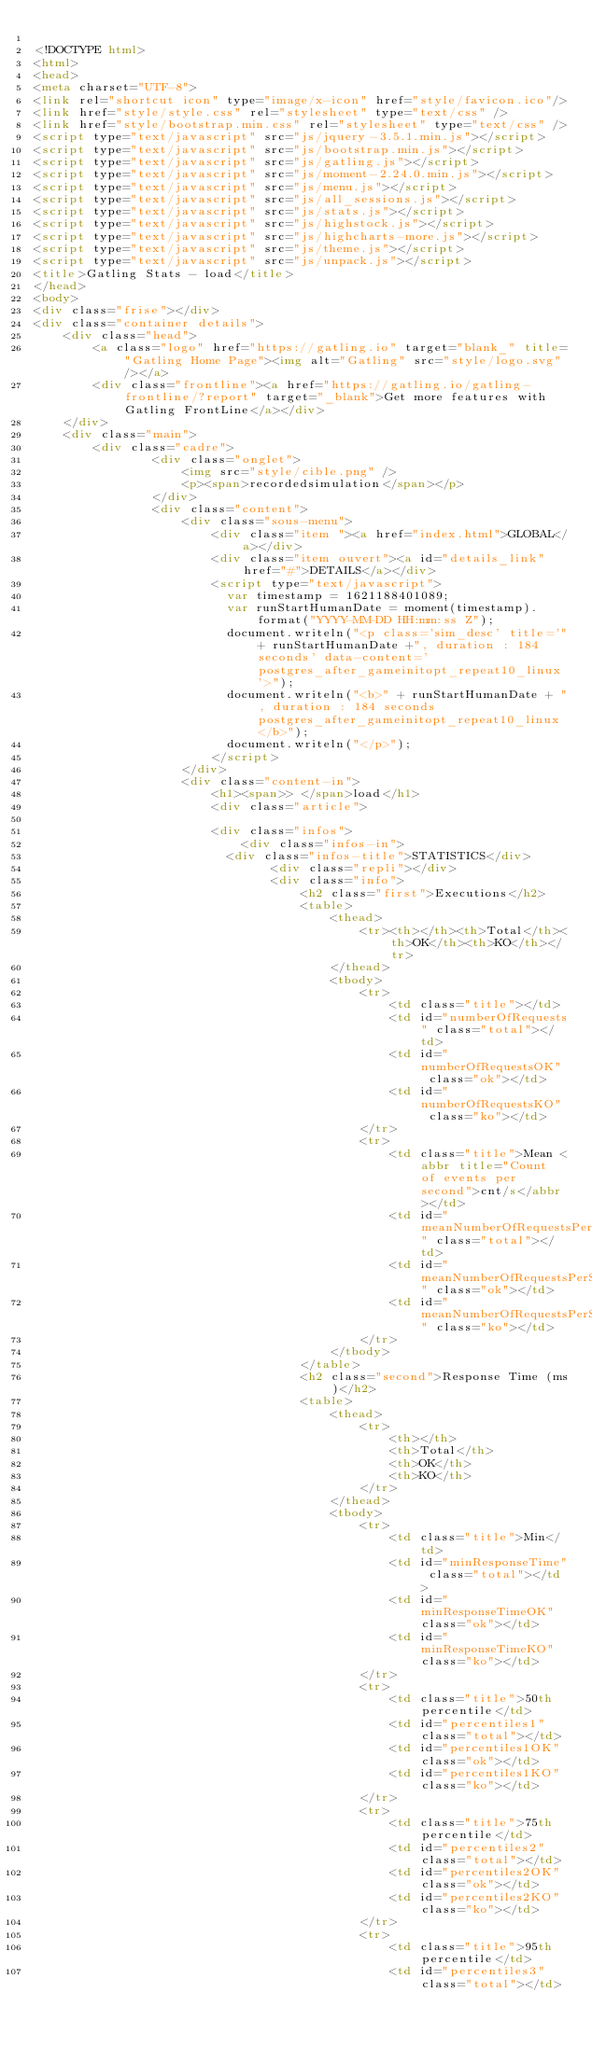Convert code to text. <code><loc_0><loc_0><loc_500><loc_500><_HTML_>
<!DOCTYPE html>
<html>
<head>
<meta charset="UTF-8">
<link rel="shortcut icon" type="image/x-icon" href="style/favicon.ico"/>
<link href="style/style.css" rel="stylesheet" type="text/css" />
<link href="style/bootstrap.min.css" rel="stylesheet" type="text/css" />
<script type="text/javascript" src="js/jquery-3.5.1.min.js"></script>
<script type="text/javascript" src="js/bootstrap.min.js"></script>
<script type="text/javascript" src="js/gatling.js"></script>
<script type="text/javascript" src="js/moment-2.24.0.min.js"></script>
<script type="text/javascript" src="js/menu.js"></script>
<script type="text/javascript" src="js/all_sessions.js"></script>
<script type="text/javascript" src="js/stats.js"></script>
<script type="text/javascript" src="js/highstock.js"></script>
<script type="text/javascript" src="js/highcharts-more.js"></script>
<script type="text/javascript" src="js/theme.js"></script>
<script type="text/javascript" src="js/unpack.js"></script>
<title>Gatling Stats - load</title>
</head>
<body>
<div class="frise"></div>
<div class="container details">
    <div class="head">
        <a class="logo" href="https://gatling.io" target="blank_" title="Gatling Home Page"><img alt="Gatling" src="style/logo.svg"/></a>
        <div class="frontline"><a href="https://gatling.io/gatling-frontline/?report" target="_blank">Get more features with Gatling FrontLine</a></div>
    </div>
    <div class="main">
        <div class="cadre">
                <div class="onglet">
                    <img src="style/cible.png" />
                    <p><span>recordedsimulation</span></p>
                </div>
                <div class="content">
                    <div class="sous-menu">
                        <div class="item "><a href="index.html">GLOBAL</a></div>
                        <div class="item ouvert"><a id="details_link" href="#">DETAILS</a></div>
                        <script type="text/javascript">
                          var timestamp = 1621188401089;
                          var runStartHumanDate = moment(timestamp).format("YYYY-MM-DD HH:mm:ss Z");
                          document.writeln("<p class='sim_desc' title='"+ runStartHumanDate +", duration : 184 seconds' data-content='postgres_after_gameinitopt_repeat10_linux'>");
                          document.writeln("<b>" + runStartHumanDate + ", duration : 184 seconds postgres_after_gameinitopt_repeat10_linux</b>");
                          document.writeln("</p>");
                        </script>
                    </div>
                    <div class="content-in">
                        <h1><span>> </span>load</h1>
                        <div class="article">
                            
                        <div class="infos">
                            <div class="infos-in">
	                        <div class="infos-title">STATISTICS</div>
                                <div class="repli"></div>                               
                                <div class="info">
                                    <h2 class="first">Executions</h2>
                                    <table>
                                        <thead>
                                            <tr><th></th><th>Total</th><th>OK</th><th>KO</th></tr>
                                        </thead>
                                        <tbody>
                                            <tr>
                                                <td class="title"></td>
                                                <td id="numberOfRequests" class="total"></td>
                                                <td id="numberOfRequestsOK" class="ok"></td>
                                                <td id="numberOfRequestsKO" class="ko"></td>
                                            </tr>
                                            <tr>
                                                <td class="title">Mean <abbr title="Count of events per second">cnt/s</abbr></td>
                                                <td id="meanNumberOfRequestsPerSecond" class="total"></td>
                                                <td id="meanNumberOfRequestsPerSecondOK" class="ok"></td>
                                                <td id="meanNumberOfRequestsPerSecondKO" class="ko"></td>
                                            </tr>
                                        </tbody>
                                    </table>
                                    <h2 class="second">Response Time (ms)</h2>
                                    <table>
                                        <thead>
                                            <tr>
                                                <th></th>
                                                <th>Total</th>
                                                <th>OK</th>
                                                <th>KO</th>
                                            </tr>
                                        </thead>
                                        <tbody>
                                            <tr>
                                                <td class="title">Min</td>
                                                <td id="minResponseTime" class="total"></td>
                                                <td id="minResponseTimeOK" class="ok"></td>
                                                <td id="minResponseTimeKO" class="ko"></td>
                                            </tr>
                                            <tr>
                                                <td class="title">50th percentile</td>
                                                <td id="percentiles1" class="total"></td>
                                                <td id="percentiles1OK" class="ok"></td>
                                                <td id="percentiles1KO" class="ko"></td>
                                            </tr>
                                            <tr>
                                                <td class="title">75th percentile</td>
                                                <td id="percentiles2" class="total"></td>
                                                <td id="percentiles2OK" class="ok"></td>
                                                <td id="percentiles2KO" class="ko"></td>
                                            </tr>
                                            <tr>
                                                <td class="title">95th percentile</td>
                                                <td id="percentiles3" class="total"></td></code> 